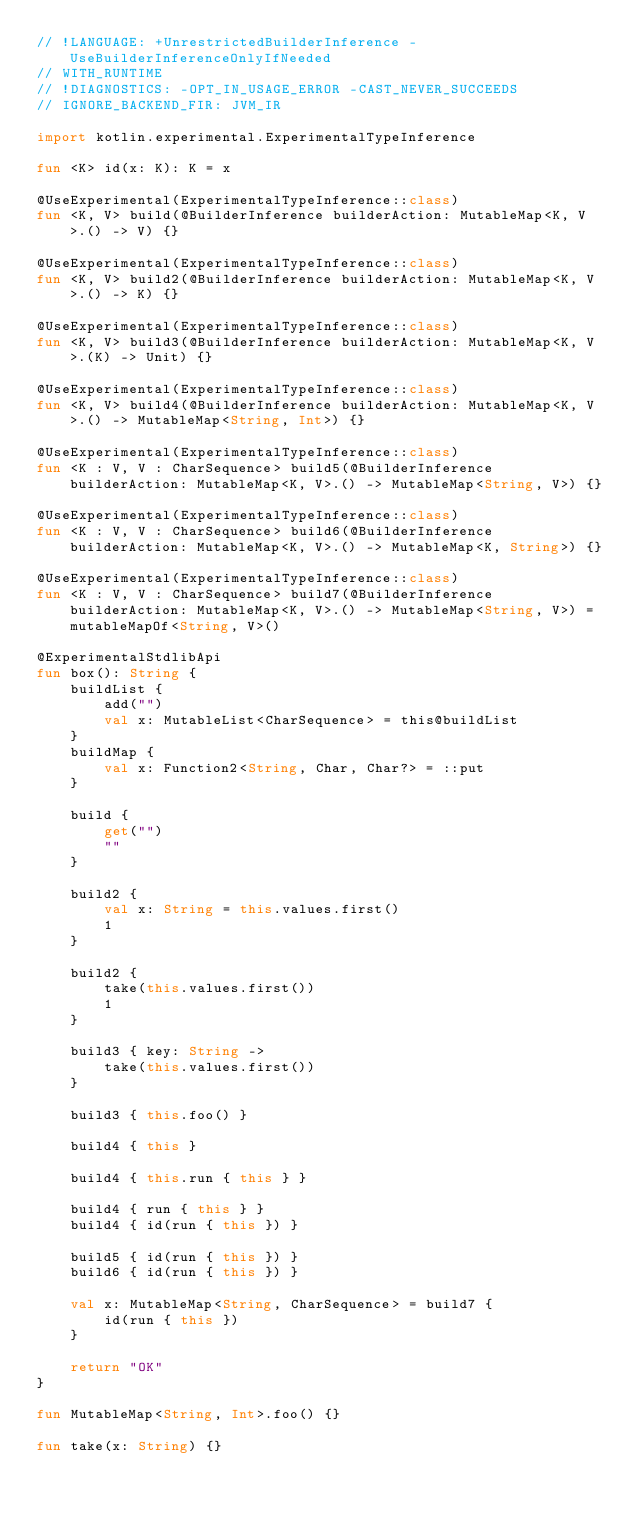Convert code to text. <code><loc_0><loc_0><loc_500><loc_500><_Kotlin_>// !LANGUAGE: +UnrestrictedBuilderInference -UseBuilderInferenceOnlyIfNeeded
// WITH_RUNTIME
// !DIAGNOSTICS: -OPT_IN_USAGE_ERROR -CAST_NEVER_SUCCEEDS
// IGNORE_BACKEND_FIR: JVM_IR

import kotlin.experimental.ExperimentalTypeInference

fun <K> id(x: K): K = x

@UseExperimental(ExperimentalTypeInference::class)
fun <K, V> build(@BuilderInference builderAction: MutableMap<K, V>.() -> V) {}

@UseExperimental(ExperimentalTypeInference::class)
fun <K, V> build2(@BuilderInference builderAction: MutableMap<K, V>.() -> K) {}

@UseExperimental(ExperimentalTypeInference::class)
fun <K, V> build3(@BuilderInference builderAction: MutableMap<K, V>.(K) -> Unit) {}

@UseExperimental(ExperimentalTypeInference::class)
fun <K, V> build4(@BuilderInference builderAction: MutableMap<K, V>.() -> MutableMap<String, Int>) {}

@UseExperimental(ExperimentalTypeInference::class)
fun <K : V, V : CharSequence> build5(@BuilderInference builderAction: MutableMap<K, V>.() -> MutableMap<String, V>) {}

@UseExperimental(ExperimentalTypeInference::class)
fun <K : V, V : CharSequence> build6(@BuilderInference builderAction: MutableMap<K, V>.() -> MutableMap<K, String>) {}

@UseExperimental(ExperimentalTypeInference::class)
fun <K : V, V : CharSequence> build7(@BuilderInference builderAction: MutableMap<K, V>.() -> MutableMap<String, V>) = mutableMapOf<String, V>()

@ExperimentalStdlibApi
fun box(): String {
    buildList {
        add("")
        val x: MutableList<CharSequence> = this@buildList
    }
    buildMap {
        val x: Function2<String, Char, Char?> = ::put
    }

    build {
        get("")
        ""
    }

    build2 {
        val x: String = this.values.first()
        1
    }

    build2 {
        take(this.values.first())
        1
    }

    build3 { key: String ->
        take(this.values.first())
    }

    build3 { this.foo() }

    build4 { this }

    build4 { this.run { this } }

    build4 { run { this } }
    build4 { id(run { this }) }

    build5 { id(run { this }) }
    build6 { id(run { this }) }

    val x: MutableMap<String, CharSequence> = build7 {
        id(run { this })
    }

    return "OK"
}

fun MutableMap<String, Int>.foo() {}

fun take(x: String) {}
</code> 